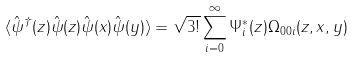Convert formula to latex. <formula><loc_0><loc_0><loc_500><loc_500>\langle \hat { \psi } ^ { \dagger } ( z ) \hat { \psi } ( z ) \hat { \psi } ( x ) \hat { \psi } ( y ) \rangle = \sqrt { 3 ! } \sum _ { i = 0 } ^ { \infty } \Psi _ { i } ^ { * } ( z ) \Omega _ { 0 0 i } ( z , x , y )</formula> 